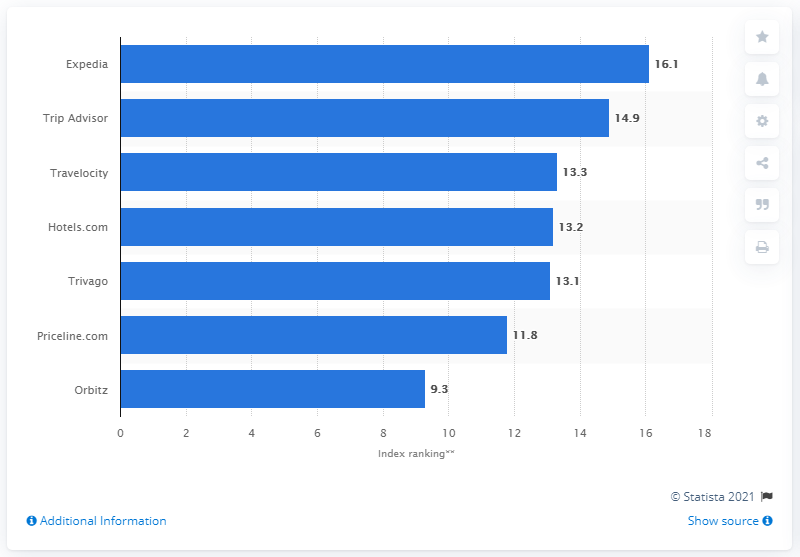Indicate a few pertinent items in this graphic. In 2018, Expedia's score was 16.1. Expedia is the travel agent that received the highest ranking with a score of 16.1. 